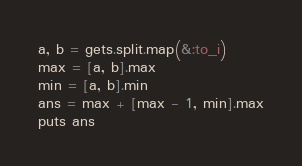<code> <loc_0><loc_0><loc_500><loc_500><_Ruby_>a, b = gets.split.map(&:to_i)
max = [a, b].max
min = [a, b].min
ans = max + [max - 1, min].max
puts ans
</code> 